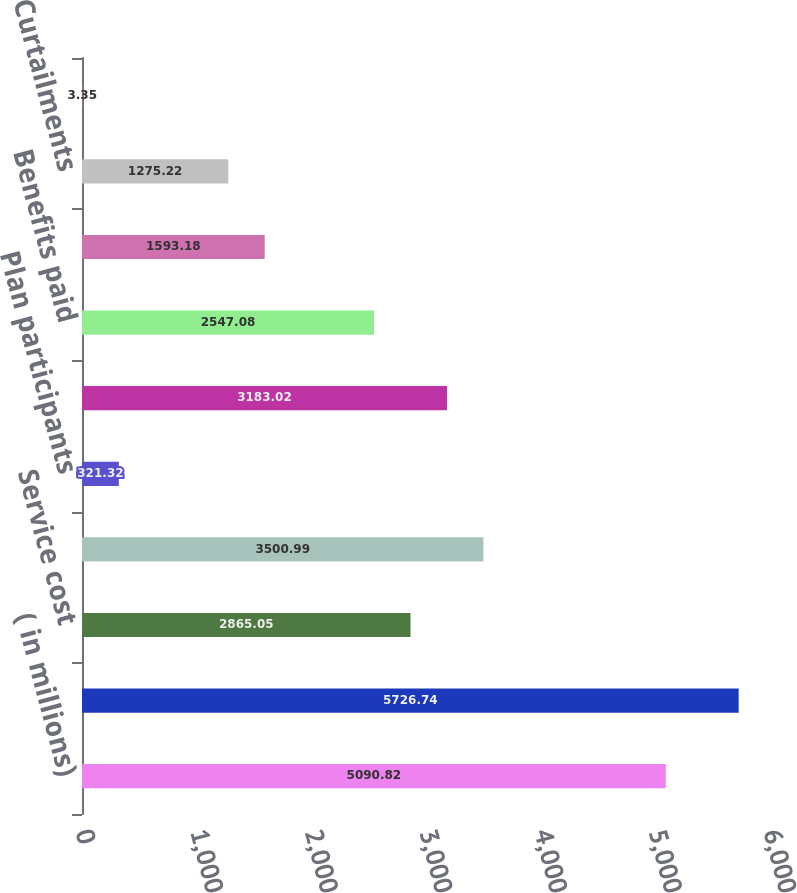Convert chart to OTSL. <chart><loc_0><loc_0><loc_500><loc_500><bar_chart><fcel>( in millions)<fcel>Benefit obligation at<fcel>Service cost<fcel>Interest cost<fcel>Plan participants<fcel>Actuarial loss (gain)<fcel>Benefits paid<fcel>Transfers<fcel>Curtailments<fcel>Medicare Part D subsidy<nl><fcel>5090.82<fcel>5726.74<fcel>2865.05<fcel>3500.99<fcel>321.32<fcel>3183.02<fcel>2547.08<fcel>1593.18<fcel>1275.22<fcel>3.35<nl></chart> 